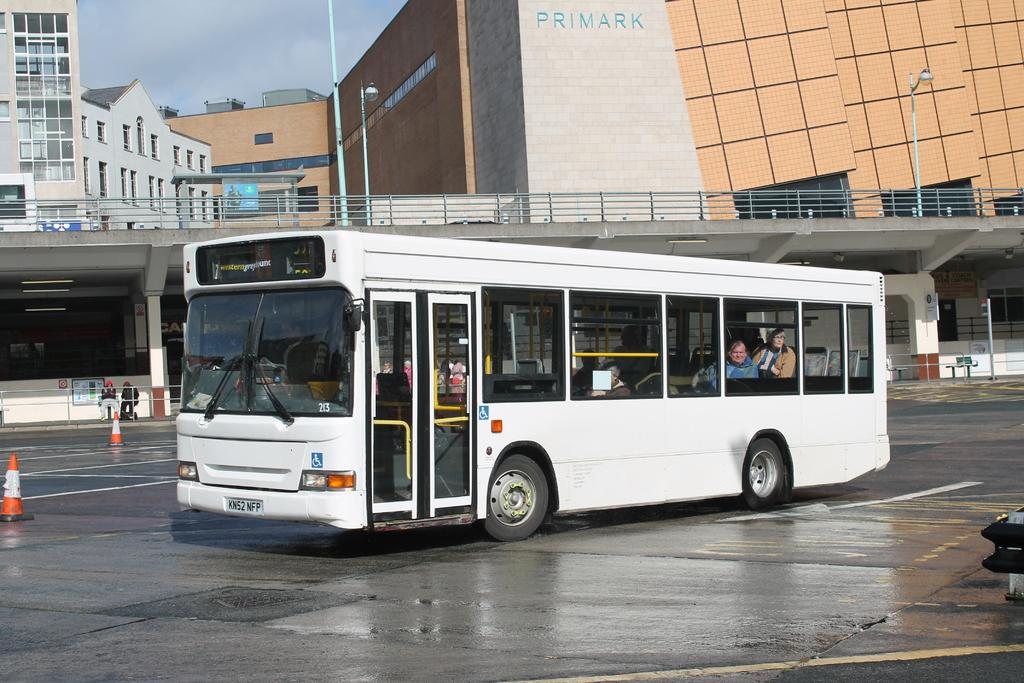What is the main subject in the middle of the picture? There is a bus in the middle of the picture. What can be seen in the background of the picture? There are buildings and the sky visible in the background of the picture. What type of force is being applied to the tooth in the image? There is no tooth present in the image, so it is not possible to determine if any force is being applied to it. 